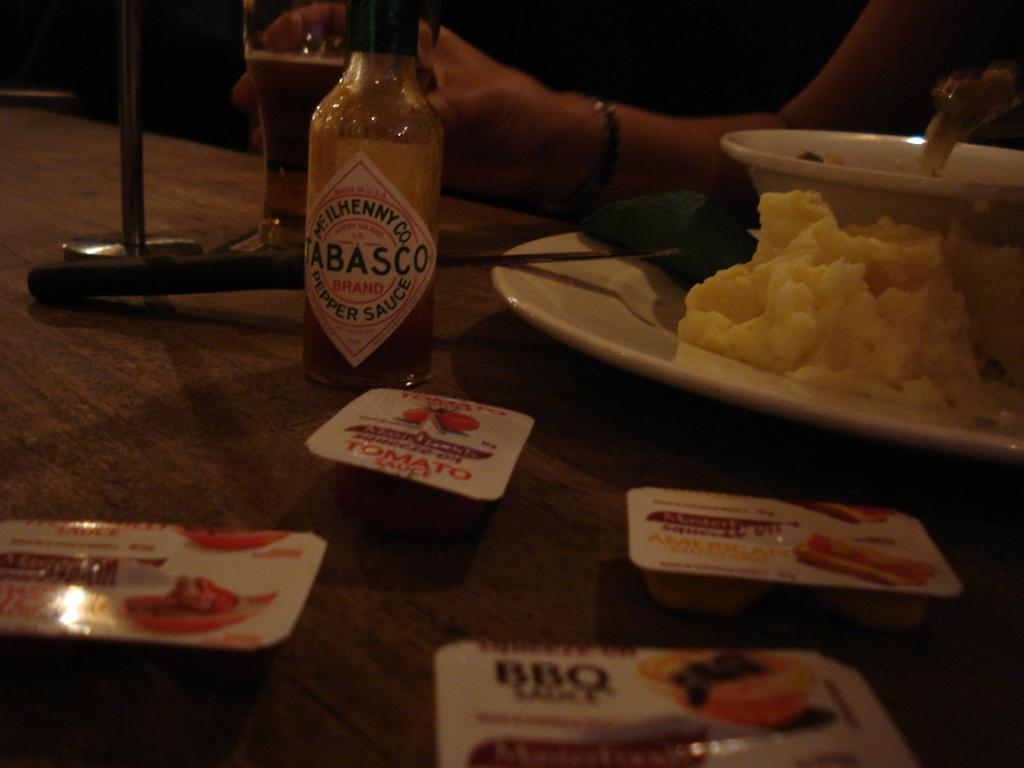Provide a one-sentence caption for the provided image. A bottle of Tabasco sauce is on a table with a plate of mashed potatoes. 